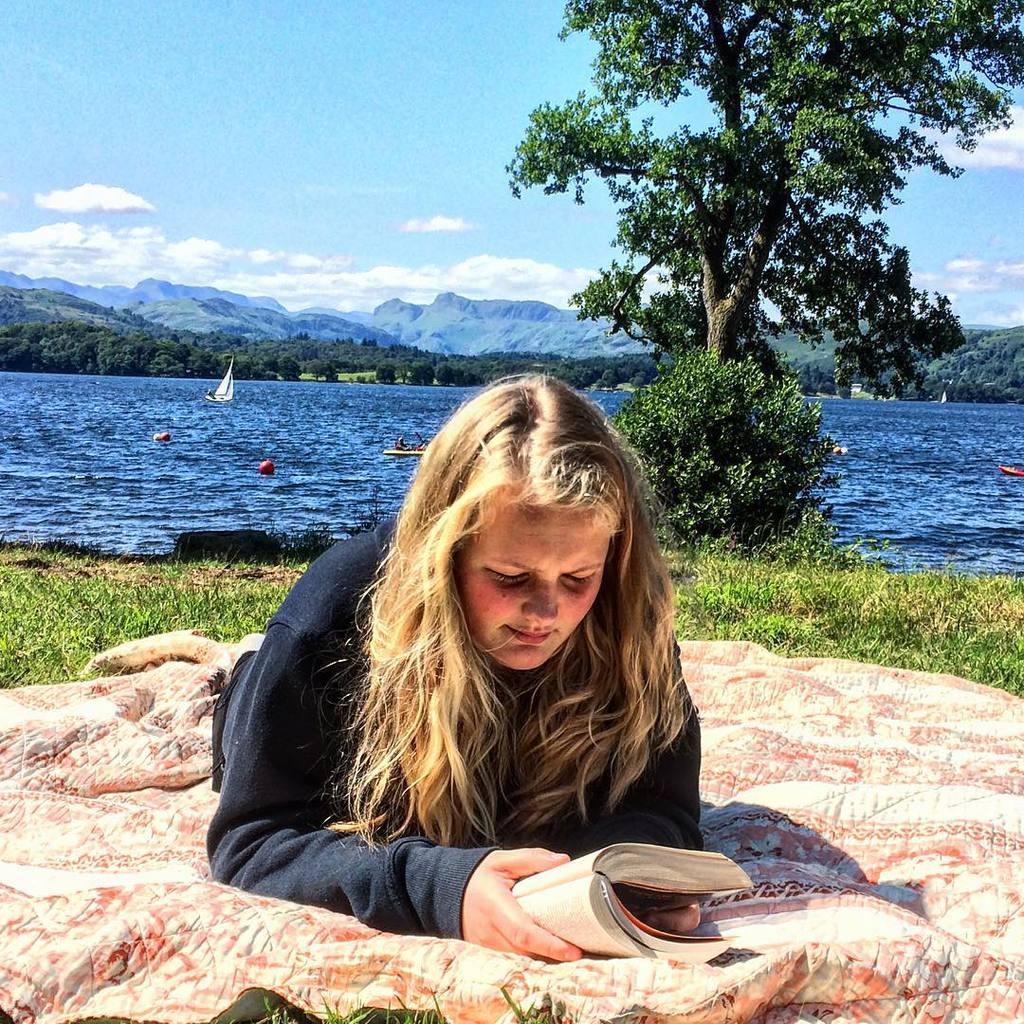How would you summarize this image in a sentence or two? In the foreground of the picture there is a woman holding book and laying on the mat. In the center of the picture there are plants, grass and tree and there is a water body, in the water there are boats. In the background there are mountains and trees and sky also. 